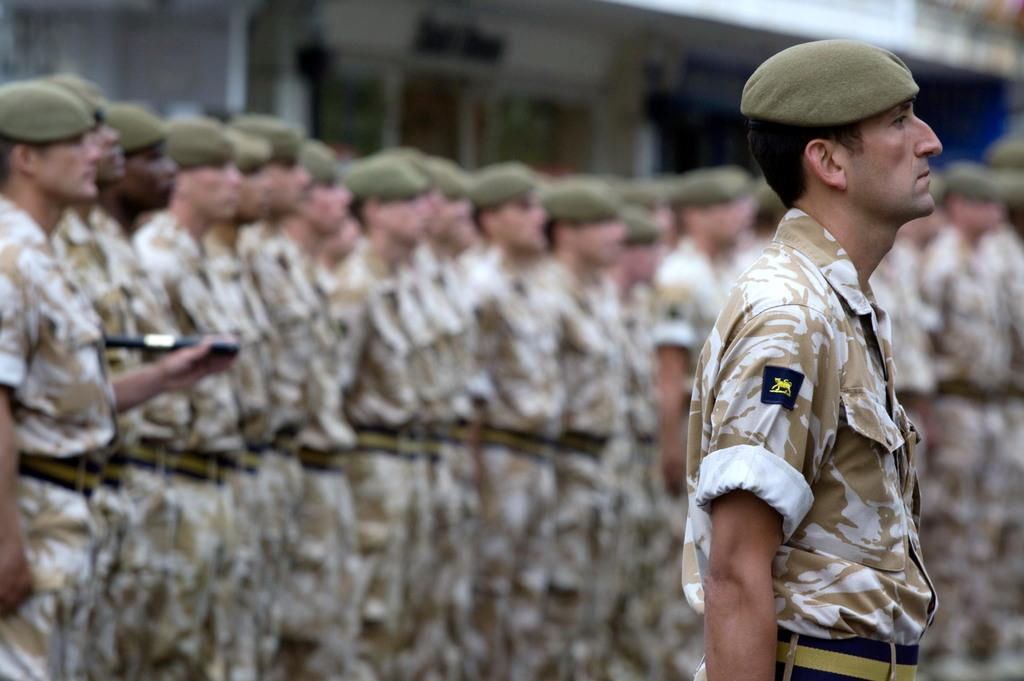What is the position of the man in the image? The man is standing on the right side of the image. What is the man wearing in the image? The man is wearing a uniform in the image. How are the people arranged in the image? The people are standing in a row in the image. What can be seen in the background of the image? There is a building in the background of the image. What type of effect does the giraffe have on the people in the image? There is no giraffe present in the image, so it cannot have any effect on the people. 